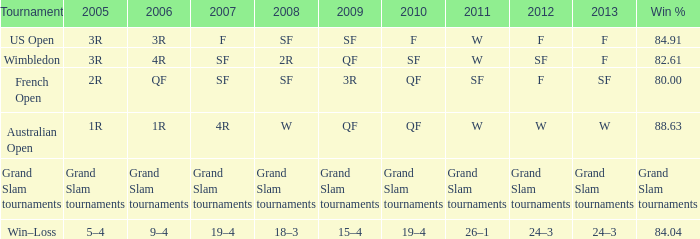61%? 3R. 